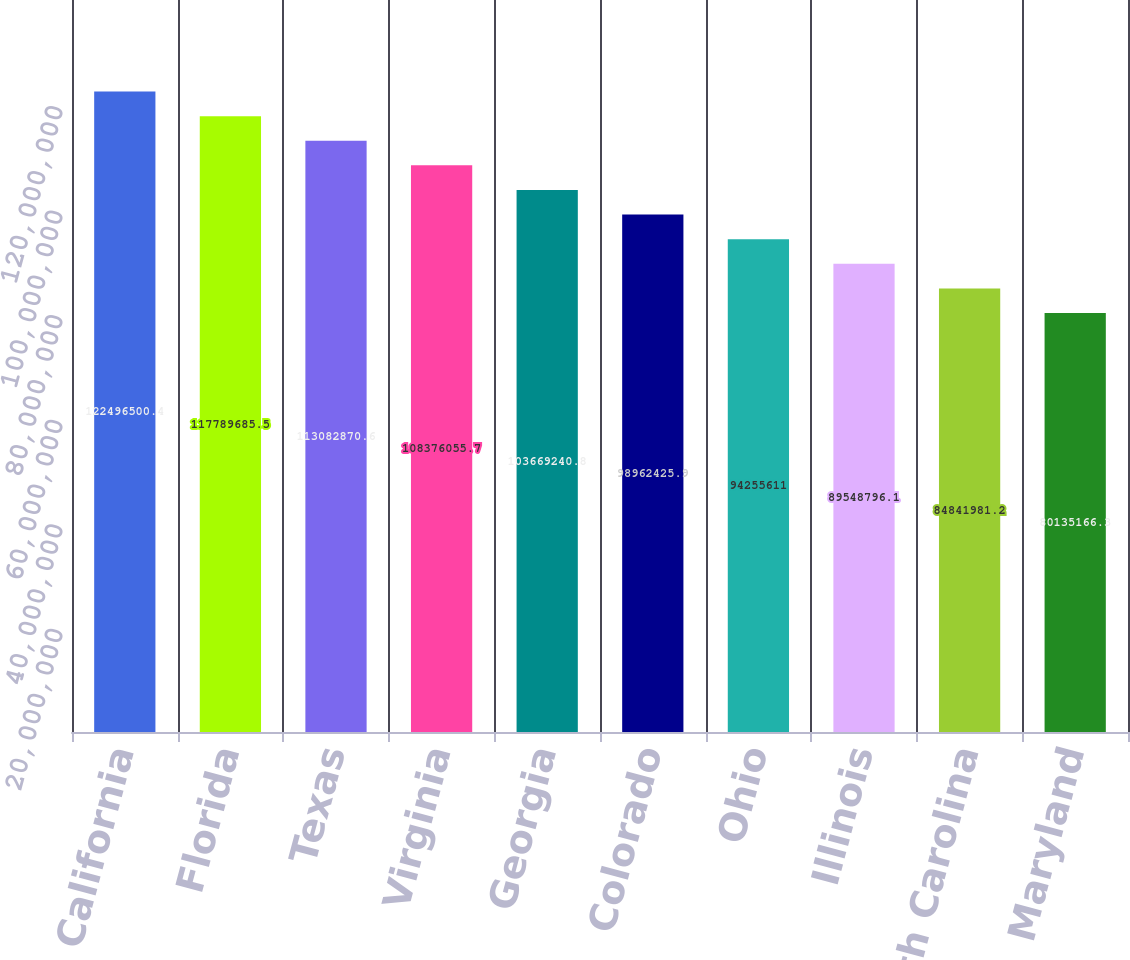<chart> <loc_0><loc_0><loc_500><loc_500><bar_chart><fcel>California<fcel>Florida<fcel>Texas<fcel>Virginia<fcel>Georgia<fcel>Colorado<fcel>Ohio<fcel>Illinois<fcel>North Carolina<fcel>Maryland<nl><fcel>1.22497e+08<fcel>1.1779e+08<fcel>1.13083e+08<fcel>1.08376e+08<fcel>1.03669e+08<fcel>9.89624e+07<fcel>9.42556e+07<fcel>8.95488e+07<fcel>8.4842e+07<fcel>8.01352e+07<nl></chart> 